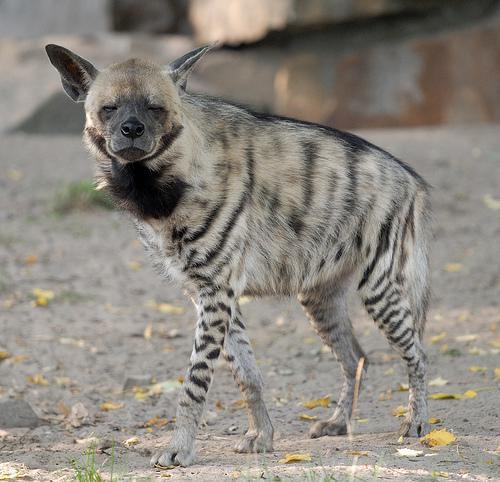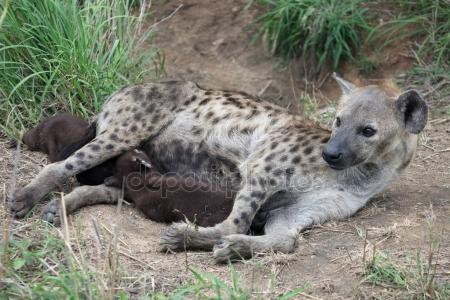The first image is the image on the left, the second image is the image on the right. Analyze the images presented: Is the assertion "There is at most two hyenas." valid? Answer yes or no. Yes. 